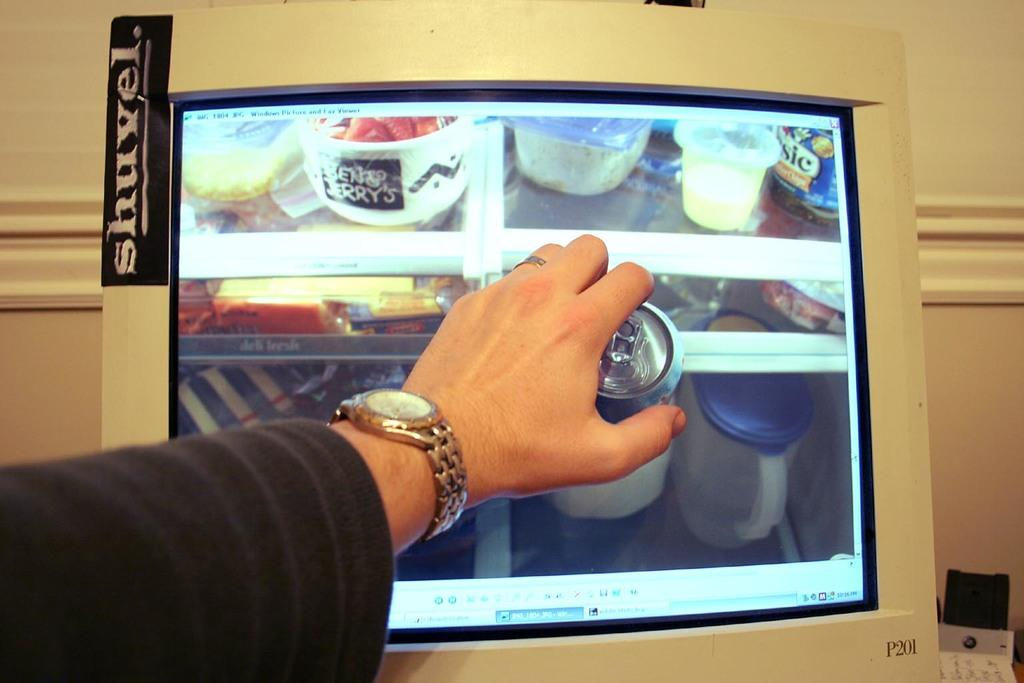<image>
Present a compact description of the photo's key features. Someone holds a can against a computer monitor with a Shuvel sticker on it. 